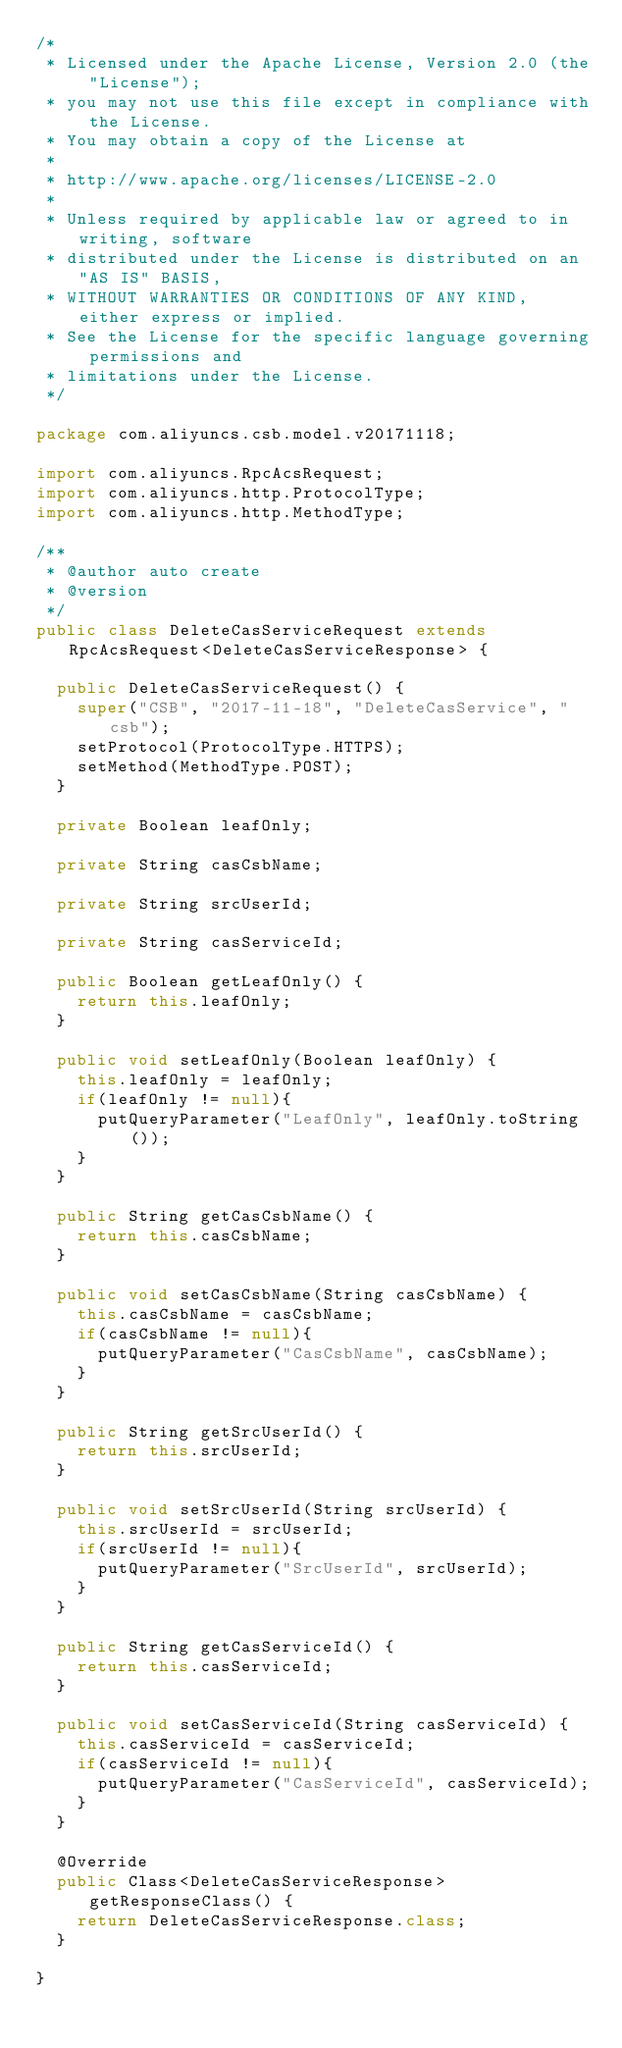<code> <loc_0><loc_0><loc_500><loc_500><_Java_>/*
 * Licensed under the Apache License, Version 2.0 (the "License");
 * you may not use this file except in compliance with the License.
 * You may obtain a copy of the License at
 *
 * http://www.apache.org/licenses/LICENSE-2.0
 *
 * Unless required by applicable law or agreed to in writing, software
 * distributed under the License is distributed on an "AS IS" BASIS,
 * WITHOUT WARRANTIES OR CONDITIONS OF ANY KIND, either express or implied.
 * See the License for the specific language governing permissions and
 * limitations under the License.
 */

package com.aliyuncs.csb.model.v20171118;

import com.aliyuncs.RpcAcsRequest;
import com.aliyuncs.http.ProtocolType;
import com.aliyuncs.http.MethodType;

/**
 * @author auto create
 * @version 
 */
public class DeleteCasServiceRequest extends RpcAcsRequest<DeleteCasServiceResponse> {
	
	public DeleteCasServiceRequest() {
		super("CSB", "2017-11-18", "DeleteCasService", "csb");
		setProtocol(ProtocolType.HTTPS);
		setMethod(MethodType.POST);
	}

	private Boolean leafOnly;

	private String casCsbName;

	private String srcUserId;

	private String casServiceId;

	public Boolean getLeafOnly() {
		return this.leafOnly;
	}

	public void setLeafOnly(Boolean leafOnly) {
		this.leafOnly = leafOnly;
		if(leafOnly != null){
			putQueryParameter("LeafOnly", leafOnly.toString());
		}
	}

	public String getCasCsbName() {
		return this.casCsbName;
	}

	public void setCasCsbName(String casCsbName) {
		this.casCsbName = casCsbName;
		if(casCsbName != null){
			putQueryParameter("CasCsbName", casCsbName);
		}
	}

	public String getSrcUserId() {
		return this.srcUserId;
	}

	public void setSrcUserId(String srcUserId) {
		this.srcUserId = srcUserId;
		if(srcUserId != null){
			putQueryParameter("SrcUserId", srcUserId);
		}
	}

	public String getCasServiceId() {
		return this.casServiceId;
	}

	public void setCasServiceId(String casServiceId) {
		this.casServiceId = casServiceId;
		if(casServiceId != null){
			putQueryParameter("CasServiceId", casServiceId);
		}
	}

	@Override
	public Class<DeleteCasServiceResponse> getResponseClass() {
		return DeleteCasServiceResponse.class;
	}

}
</code> 